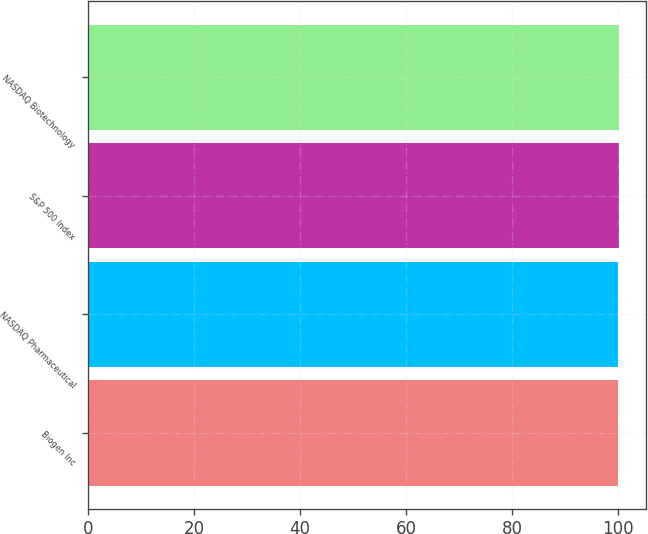<chart> <loc_0><loc_0><loc_500><loc_500><bar_chart><fcel>Biogen Inc<fcel>NASDAQ Pharmaceutical<fcel>S&P 500 Index<fcel>NASDAQ Biotechnology<nl><fcel>100<fcel>100.1<fcel>100.2<fcel>100.3<nl></chart> 